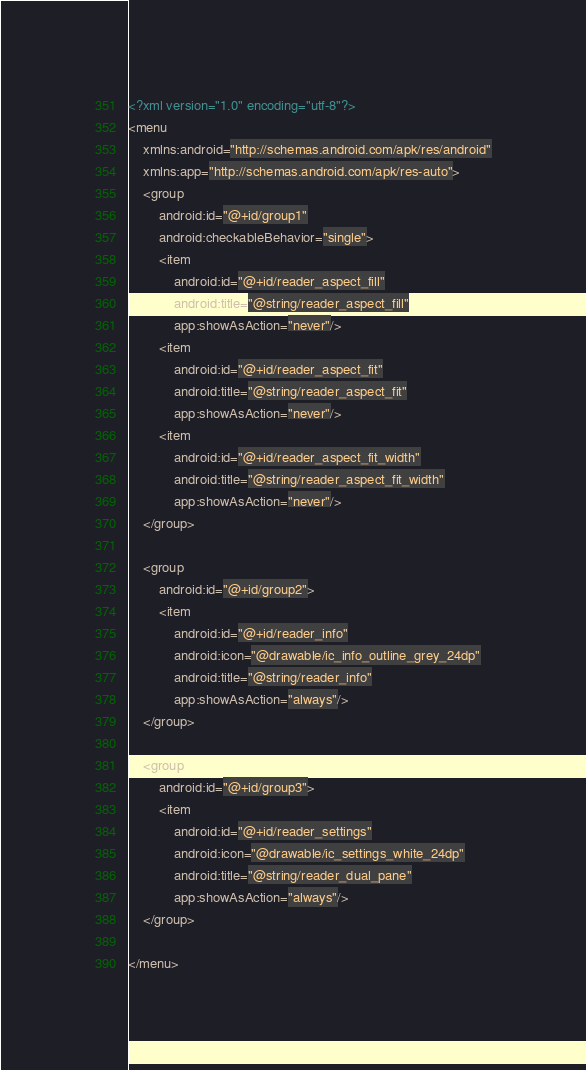Convert code to text. <code><loc_0><loc_0><loc_500><loc_500><_XML_><?xml version="1.0" encoding="utf-8"?>
<menu
    xmlns:android="http://schemas.android.com/apk/res/android"
    xmlns:app="http://schemas.android.com/apk/res-auto">
    <group
        android:id="@+id/group1"
        android:checkableBehavior="single">
        <item
            android:id="@+id/reader_aspect_fill"
            android:title="@string/reader_aspect_fill"
            app:showAsAction="never"/>
        <item
            android:id="@+id/reader_aspect_fit"
            android:title="@string/reader_aspect_fit"
            app:showAsAction="never"/>
        <item
            android:id="@+id/reader_aspect_fit_width"
            android:title="@string/reader_aspect_fit_width"
            app:showAsAction="never"/>
    </group>

    <group
        android:id="@+id/group2">
        <item
            android:id="@+id/reader_info"
            android:icon="@drawable/ic_info_outline_grey_24dp"
            android:title="@string/reader_info"
            app:showAsAction="always"/>
    </group>

    <group
        android:id="@+id/group3">
        <item
            android:id="@+id/reader_settings"
            android:icon="@drawable/ic_settings_white_24dp"
            android:title="@string/reader_dual_pane"
            app:showAsAction="always"/>
    </group>

</menu></code> 